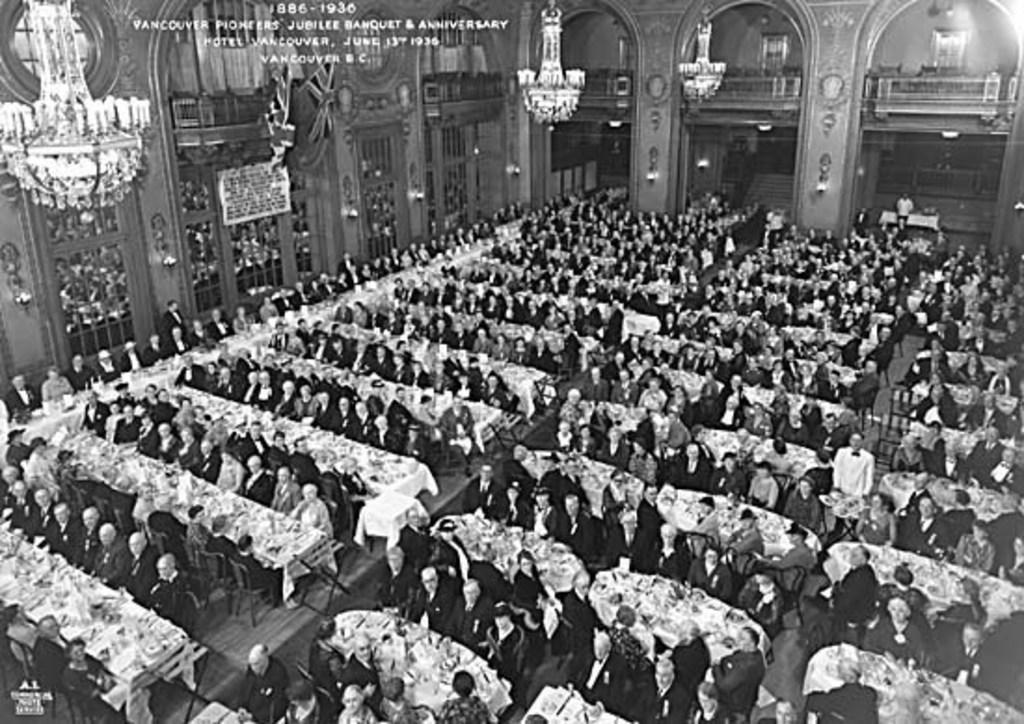What are the people in the image doing? The people in the image are sitting around tables. What type of lighting is present in the image? There are chandeliers and lamps in the image. What architectural feature can be seen in the image? There are arches in the image. Is there any text visible in the image? Yes, there is text in the image. How many birds are perched on the chandeliers in the image? There are no birds present in the image; it only features people, tables, chandeliers, lamps, arches, and text. 